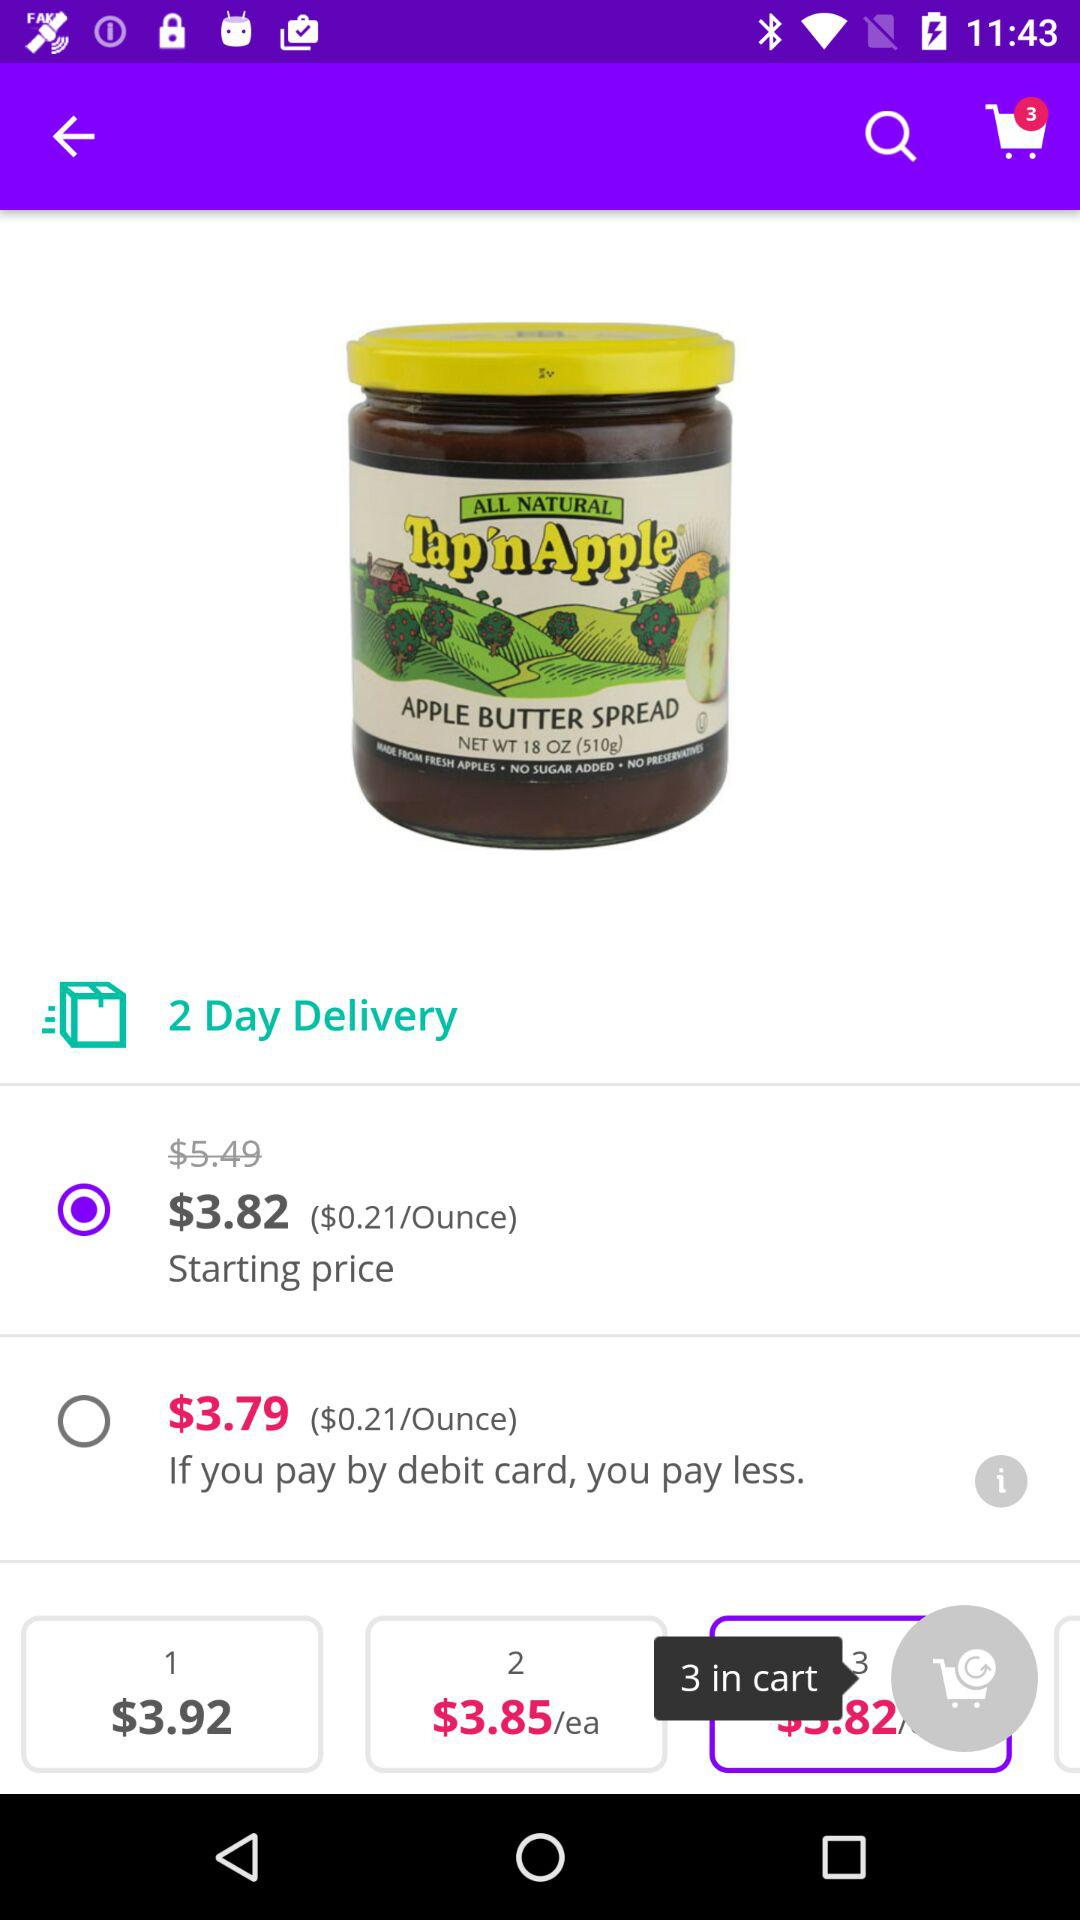Which price is shown at number 2? The price is $3.85/ea. 